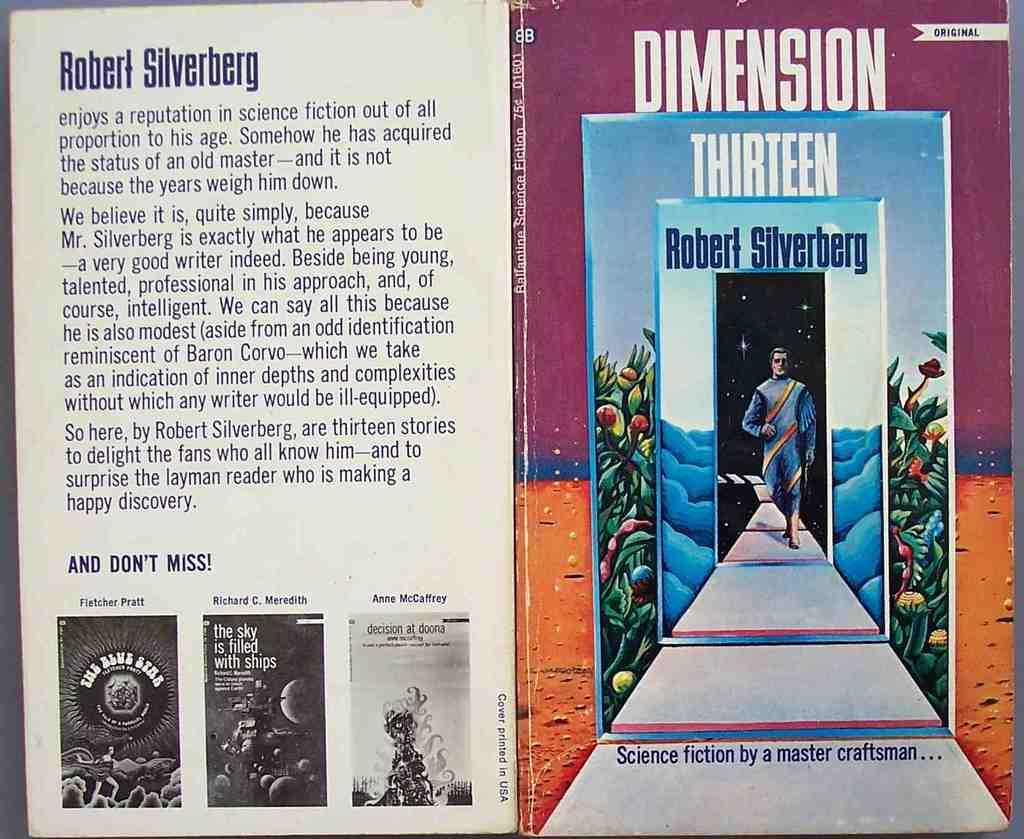<image>
Offer a succinct explanation of the picture presented. a book that says 'dimension thirteen' by robert silverberg at the top 